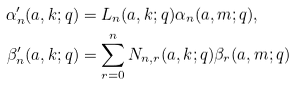Convert formula to latex. <formula><loc_0><loc_0><loc_500><loc_500>\alpha ^ { \prime } _ { n } ( a , k ; q ) & = L _ { n } ( a , k ; q ) \alpha _ { n } ( a , m ; q ) , \\ \beta ^ { \prime } _ { n } ( a , k ; q ) & = \sum _ { r = 0 } ^ { n } N _ { n , r } ( a , k ; q ) \beta _ { r } ( a , m ; q )</formula> 